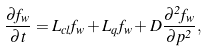Convert formula to latex. <formula><loc_0><loc_0><loc_500><loc_500>\frac { \partial f _ { w } } { \partial t } = L _ { c l } f _ { w } + L _ { q } f _ { w } + D \frac { \partial ^ { 2 } f _ { w } } { \partial p ^ { 2 } } ,</formula> 